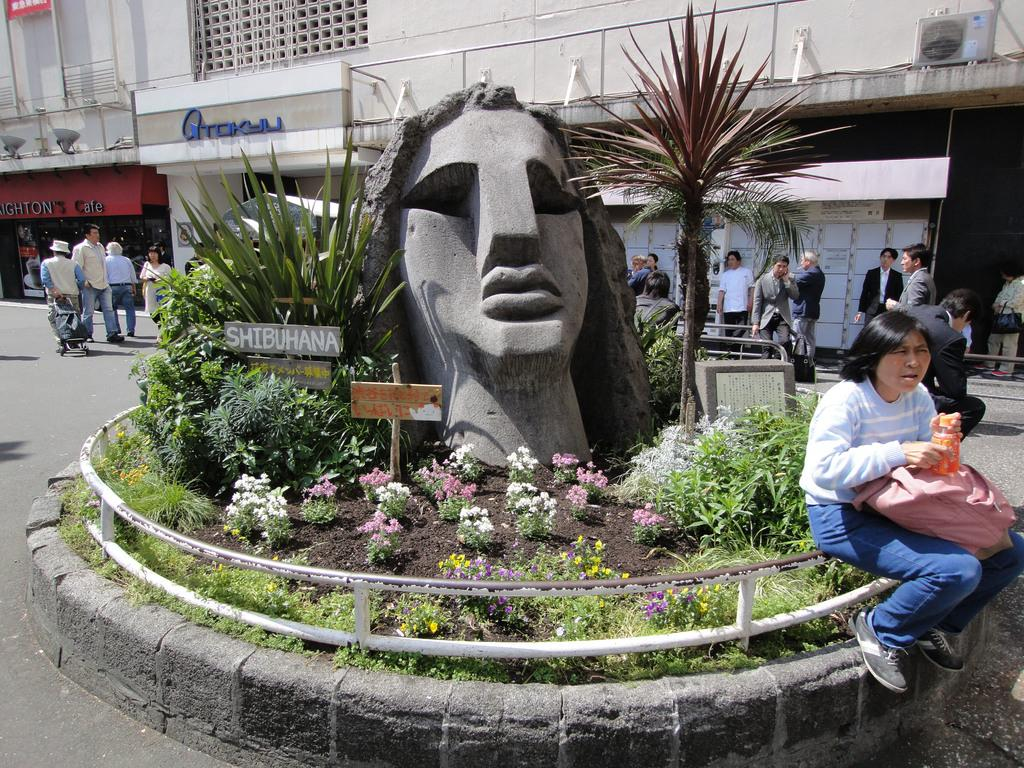What is the main subject in the middle of the image? There is a statue in the middle of the image. What can be seen around the statue? There are plants around the statue. What is the woman doing in the image? A woman is sitting on the fence of the statue. What are the people near the wall doing? Near the wall, there are people standing. What is happening on the road in the image? People are walking on the road. What type of paste is being used by the statue in the image? There is no paste being used by the statue in the image; it is a stationary object. 